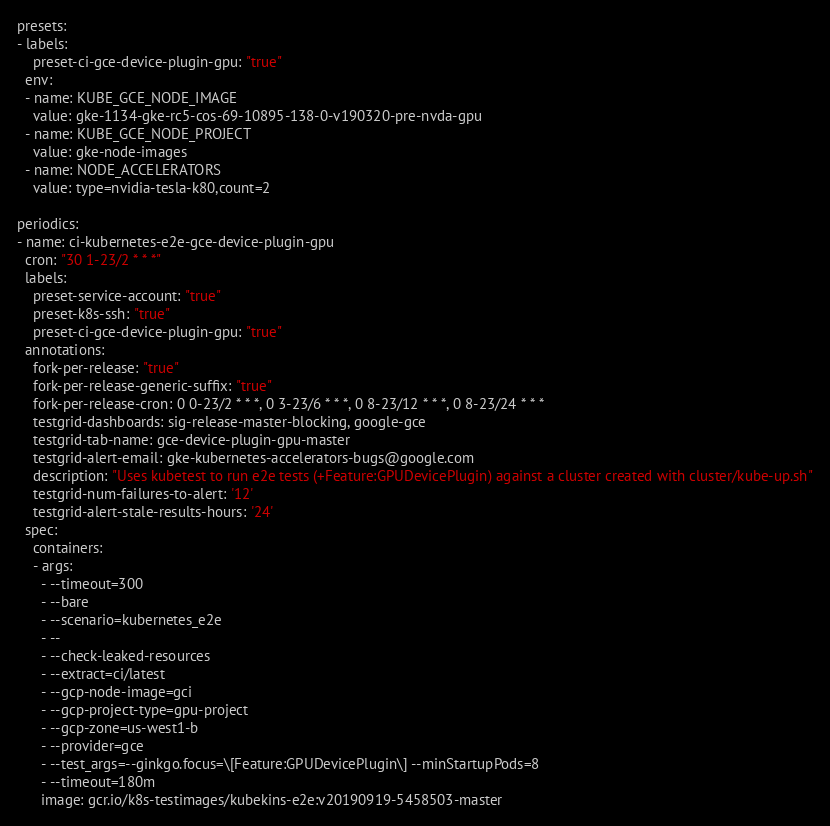Convert code to text. <code><loc_0><loc_0><loc_500><loc_500><_YAML_>presets:
- labels:
    preset-ci-gce-device-plugin-gpu: "true"
  env:
  - name: KUBE_GCE_NODE_IMAGE
    value: gke-1134-gke-rc5-cos-69-10895-138-0-v190320-pre-nvda-gpu
  - name: KUBE_GCE_NODE_PROJECT
    value: gke-node-images
  - name: NODE_ACCELERATORS
    value: type=nvidia-tesla-k80,count=2

periodics:
- name: ci-kubernetes-e2e-gce-device-plugin-gpu
  cron: "30 1-23/2 * * *"
  labels:
    preset-service-account: "true"
    preset-k8s-ssh: "true"
    preset-ci-gce-device-plugin-gpu: "true"
  annotations:
    fork-per-release: "true"
    fork-per-release-generic-suffix: "true"
    fork-per-release-cron: 0 0-23/2 * * *, 0 3-23/6 * * *, 0 8-23/12 * * *, 0 8-23/24 * * *
    testgrid-dashboards: sig-release-master-blocking, google-gce
    testgrid-tab-name: gce-device-plugin-gpu-master
    testgrid-alert-email: gke-kubernetes-accelerators-bugs@google.com
    description: "Uses kubetest to run e2e tests (+Feature:GPUDevicePlugin) against a cluster created with cluster/kube-up.sh"
    testgrid-num-failures-to-alert: '12'
    testgrid-alert-stale-results-hours: '24'
  spec:
    containers:
    - args:
      - --timeout=300
      - --bare
      - --scenario=kubernetes_e2e
      - --
      - --check-leaked-resources
      - --extract=ci/latest
      - --gcp-node-image=gci
      - --gcp-project-type=gpu-project
      - --gcp-zone=us-west1-b
      - --provider=gce
      - --test_args=--ginkgo.focus=\[Feature:GPUDevicePlugin\] --minStartupPods=8
      - --timeout=180m
      image: gcr.io/k8s-testimages/kubekins-e2e:v20190919-5458503-master
</code> 